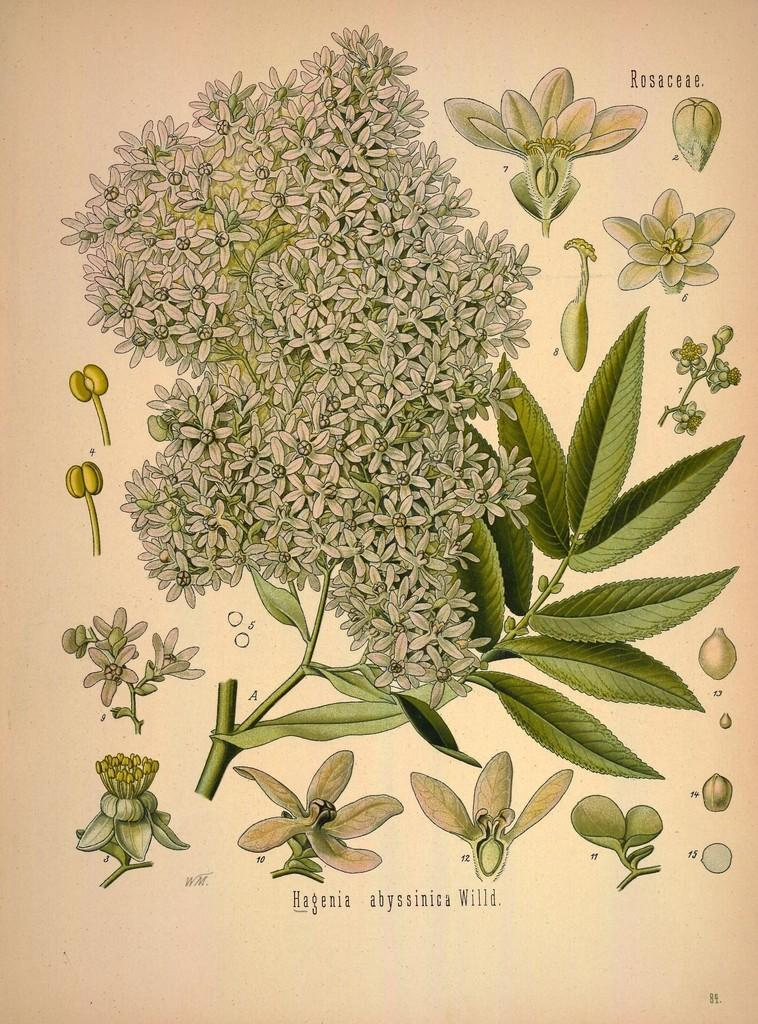What is the main subject of the image? The main subject of the image is a picture of a plant with flowers. What else can be seen in the image besides the picture of the plant? There is text visible in the image, and there are additional flowers beside the picture. What type of collar is the plant wearing in the image? There is no collar present in the image; it is a picture of a plant with flowers. 